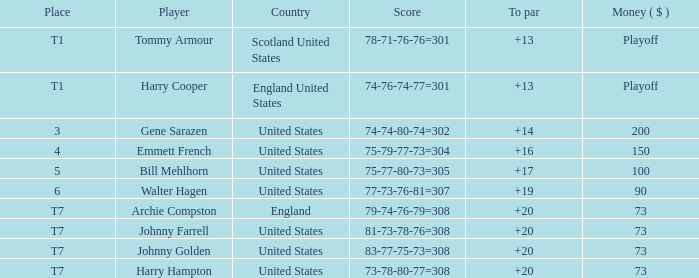What is the score for the United States when Harry Hampton is the player and the money is $73? 73-78-80-77=308. 